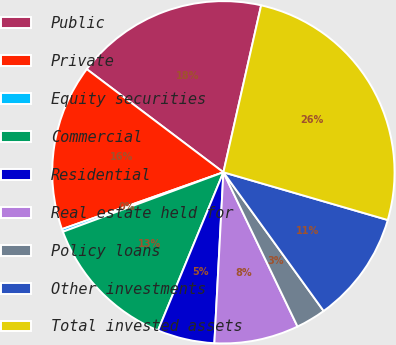Convert chart. <chart><loc_0><loc_0><loc_500><loc_500><pie_chart><fcel>Public<fcel>Private<fcel>Equity securities<fcel>Commercial<fcel>Residential<fcel>Real estate held for<fcel>Policy loans<fcel>Other investments<fcel>Total invested assets<nl><fcel>18.25%<fcel>15.68%<fcel>0.26%<fcel>13.11%<fcel>5.4%<fcel>7.97%<fcel>2.83%<fcel>10.54%<fcel>25.96%<nl></chart> 